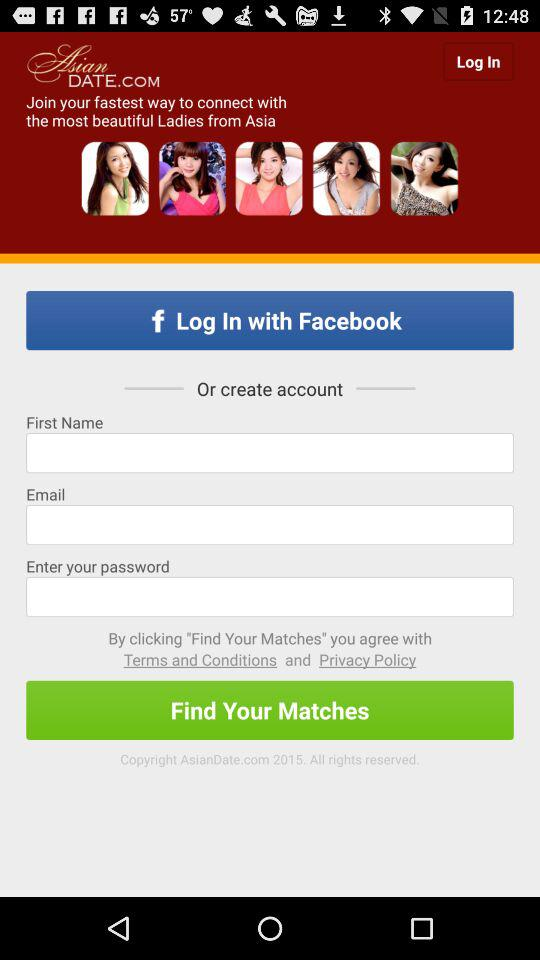What application can be used to log in? The application that can be used to log in is "Facebook". 